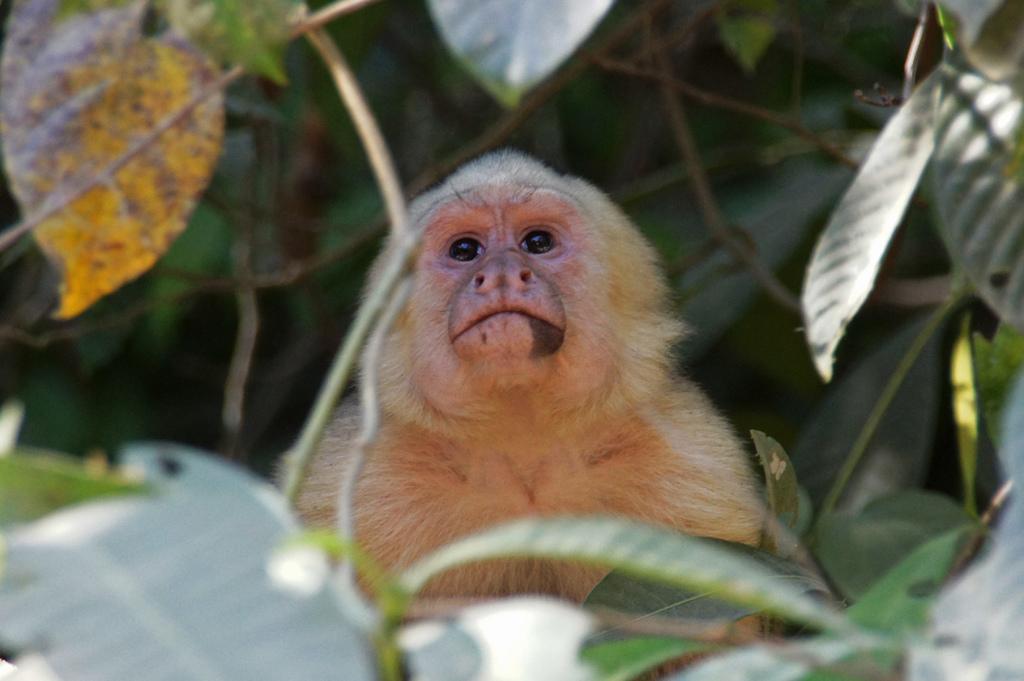Could you give a brief overview of what you see in this image? In this image I can see a monkey and plants. 